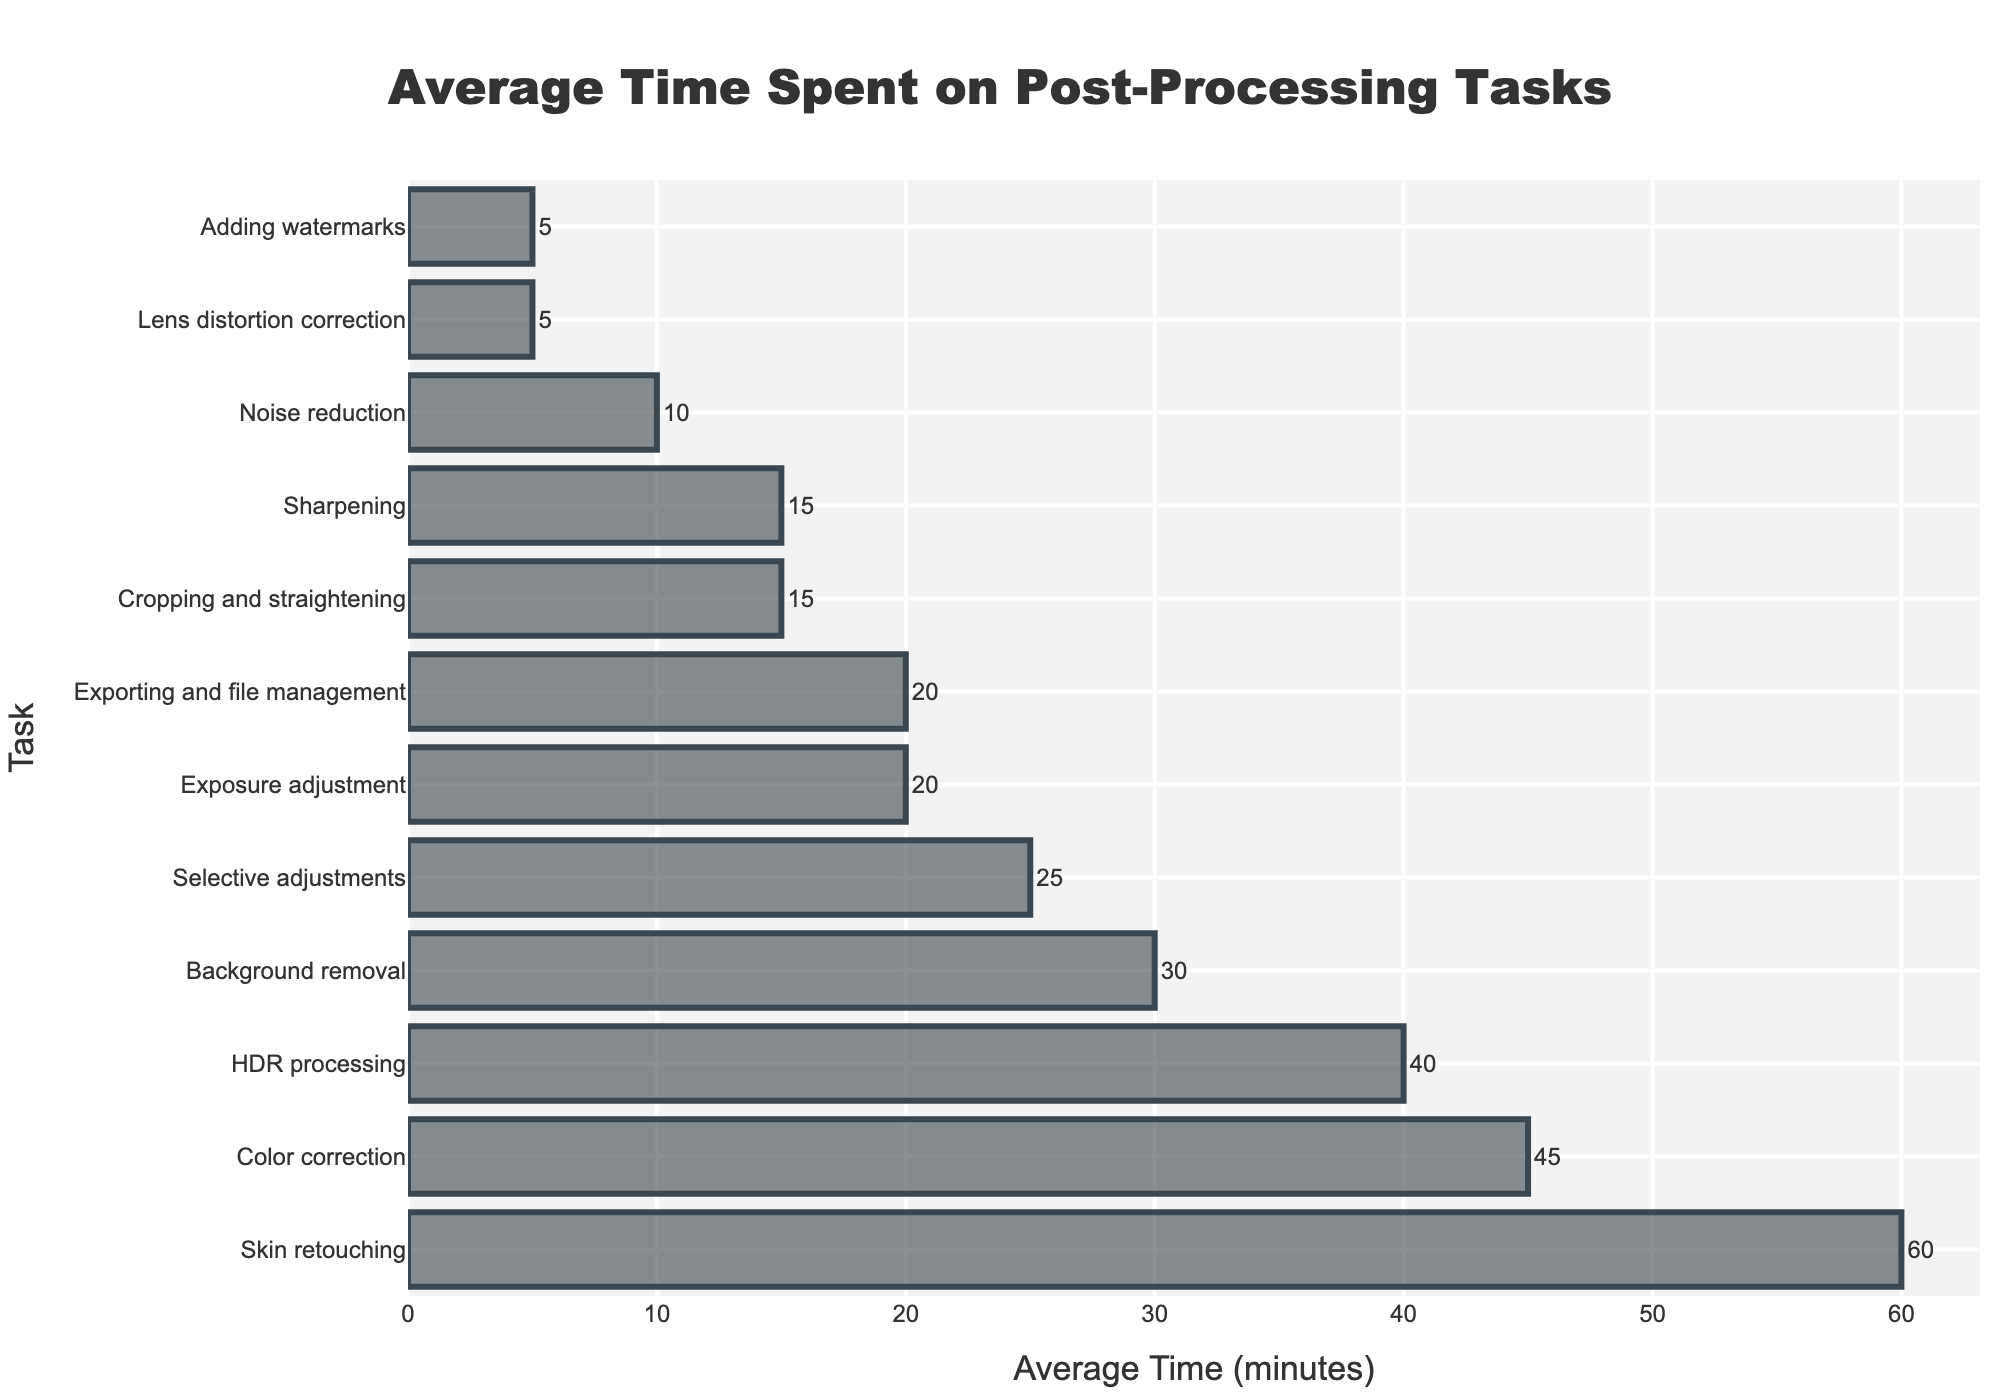Which task is the most time-consuming? The bar representing skin retouching is the longest, indicating it takes the most time.
Answer: Skin retouching Which tasks take 20 minutes on average? By looking at the bar lengths and their corresponding labels, exposure adjustment and exporting and file management both have bars indicating 20 minutes.
Answer: Exposure adjustment, Exporting and file management What is the total time spent on color correction, exposure adjustment, and cropping and straightening? Sum the times for these tasks: 45 (color correction) + 20 (exposure adjustment) + 15 (cropping and straightening).
Answer: 80 minutes How does the time spent on noise reduction compare to lens distortion correction? The bar for noise reduction is longer than the bar for lens distortion correction, indicating more time is spent on noise reduction.
Answer: Noise reduction is longer Which task takes exactly 5 minutes? Look at the bars with labels and find the one that marks 5 minutes. By observing the chart, lens distortion correction and adding watermarks are both 5 minutes.
Answer: Lens distortion correction, Adding watermarks How much more time is spent on skin retouching than on background removal? Subtract the time for background removal from the time for skin retouching: 60 (skin retouching) - 30 (background removal).
Answer: 30 minutes What is the average time spent on HDR processing and selective adjustments? Calculate the average by summing the times for HDR processing and selective adjustments and dividing by 2: (40 + 25) / 2.
Answer: 32.5 minutes Are the bars for sharpening and cropping and straightening of equal length? By visually comparing the bars for sharpening and cropping and straightening, one can see that they are of equal length.
Answer: Yes Which tasks take less than 10 minutes? Observing the chart, lens distortion correction and adding watermarks take less than 10 minutes.
Answer: Lens distortion correction, Adding watermarks Is the time spent on HDR processing greater than or equal to the time spent on background removal? Comparing the bar lengths for HDR processing and background removal, HDR processing is longer.
Answer: Yes 